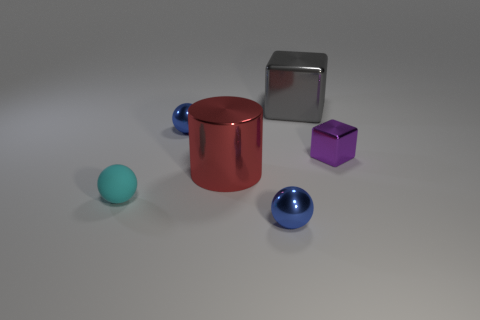Add 1 big cylinders. How many objects exist? 7 Subtract all cylinders. How many objects are left? 5 Add 6 tiny red metallic balls. How many tiny red metallic balls exist? 6 Subtract 0 red cubes. How many objects are left? 6 Subtract all tiny blue things. Subtract all tiny blue metallic objects. How many objects are left? 2 Add 2 cylinders. How many cylinders are left? 3 